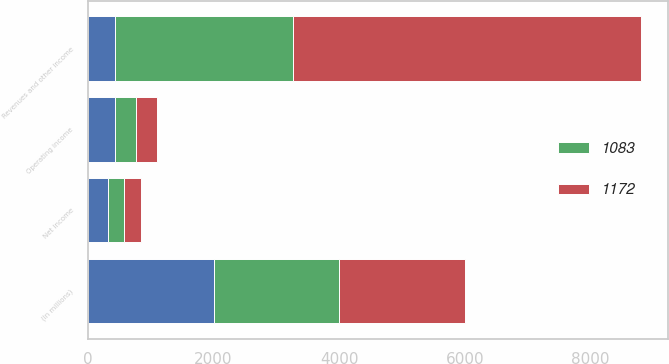<chart> <loc_0><loc_0><loc_500><loc_500><stacked_bar_chart><ecel><fcel>(In millions)<fcel>Revenues and other income<fcel>Operating income<fcel>Net income<nl><fcel>nan<fcel>2003<fcel>435<fcel>435<fcel>319<nl><fcel>1172<fcel>2002<fcel>5541<fcel>329<fcel>264<nl><fcel>1083<fcel>2001<fcel>2824<fcel>332<fcel>257<nl></chart> 